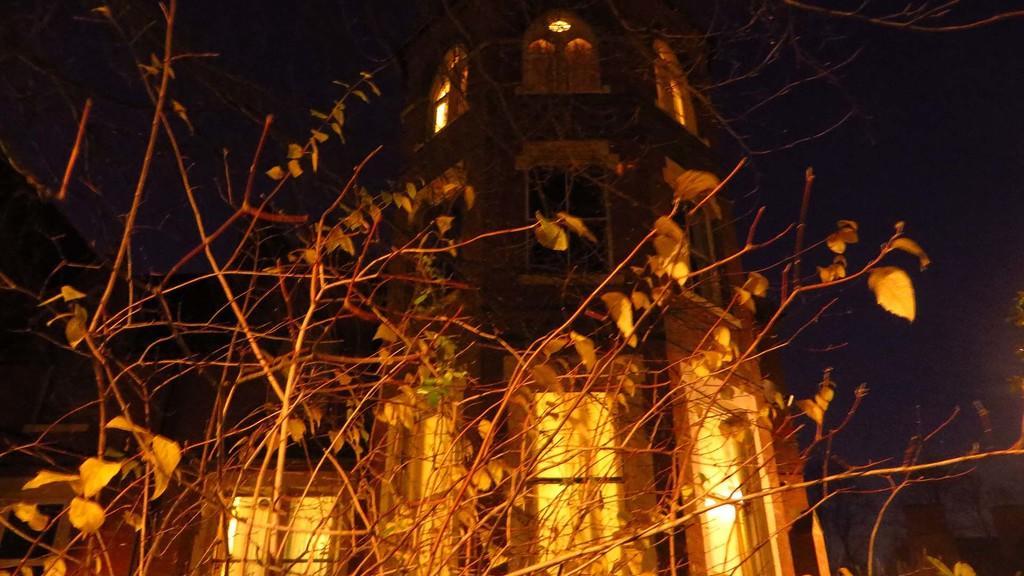Describe this image in one or two sentences. In this picture we can see a building, lights and trees. 